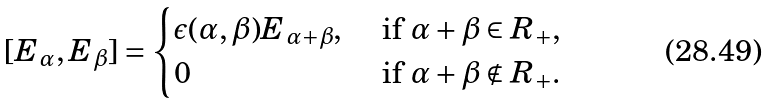Convert formula to latex. <formula><loc_0><loc_0><loc_500><loc_500>[ E _ { \alpha } , E _ { \beta } ] = \begin{cases} \epsilon ( \alpha , \beta ) E _ { \alpha + \beta } , & \text { if } \alpha + \beta \in R _ { + } , \\ 0 & \text { if } \alpha + \beta \notin R _ { + } . \end{cases}</formula> 